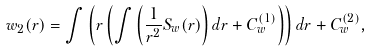<formula> <loc_0><loc_0><loc_500><loc_500>w _ { 2 } ( r ) = \int \left ( r \left ( \int \left ( \frac { 1 } { r ^ { 2 } } S _ { w } ( r ) \right ) d r + C _ { w } ^ { ( 1 ) } \right ) \right ) d r + C _ { w } ^ { ( 2 ) } ,</formula> 